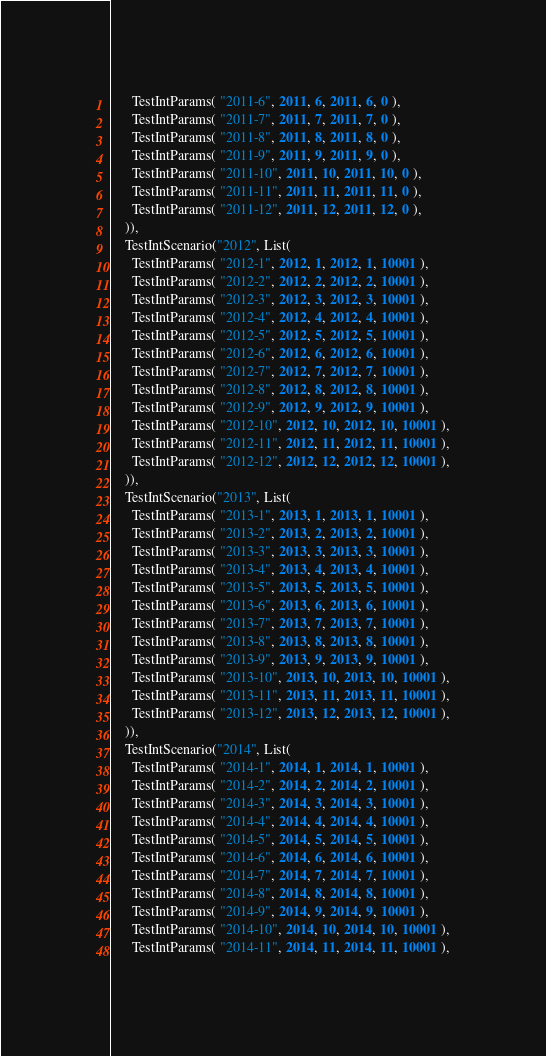Convert code to text. <code><loc_0><loc_0><loc_500><loc_500><_Scala_>      TestIntParams( "2011-6", 2011, 6, 2011, 6, 0 ),
      TestIntParams( "2011-7", 2011, 7, 2011, 7, 0 ),
      TestIntParams( "2011-8", 2011, 8, 2011, 8, 0 ),
      TestIntParams( "2011-9", 2011, 9, 2011, 9, 0 ),
      TestIntParams( "2011-10", 2011, 10, 2011, 10, 0 ),
      TestIntParams( "2011-11", 2011, 11, 2011, 11, 0 ),
      TestIntParams( "2011-12", 2011, 12, 2011, 12, 0 ),
    )),
    TestIntScenario("2012", List(
      TestIntParams( "2012-1", 2012, 1, 2012, 1, 10001 ),
      TestIntParams( "2012-2", 2012, 2, 2012, 2, 10001 ),
      TestIntParams( "2012-3", 2012, 3, 2012, 3, 10001 ),
      TestIntParams( "2012-4", 2012, 4, 2012, 4, 10001 ),
      TestIntParams( "2012-5", 2012, 5, 2012, 5, 10001 ),
      TestIntParams( "2012-6", 2012, 6, 2012, 6, 10001 ),
      TestIntParams( "2012-7", 2012, 7, 2012, 7, 10001 ),
      TestIntParams( "2012-8", 2012, 8, 2012, 8, 10001 ),
      TestIntParams( "2012-9", 2012, 9, 2012, 9, 10001 ),
      TestIntParams( "2012-10", 2012, 10, 2012, 10, 10001 ),
      TestIntParams( "2012-11", 2012, 11, 2012, 11, 10001 ),
      TestIntParams( "2012-12", 2012, 12, 2012, 12, 10001 ),
    )),
    TestIntScenario("2013", List(
      TestIntParams( "2013-1", 2013, 1, 2013, 1, 10001 ),
      TestIntParams( "2013-2", 2013, 2, 2013, 2, 10001 ),
      TestIntParams( "2013-3", 2013, 3, 2013, 3, 10001 ),
      TestIntParams( "2013-4", 2013, 4, 2013, 4, 10001 ),
      TestIntParams( "2013-5", 2013, 5, 2013, 5, 10001 ),
      TestIntParams( "2013-6", 2013, 6, 2013, 6, 10001 ),
      TestIntParams( "2013-7", 2013, 7, 2013, 7, 10001 ),
      TestIntParams( "2013-8", 2013, 8, 2013, 8, 10001 ),
      TestIntParams( "2013-9", 2013, 9, 2013, 9, 10001 ),
      TestIntParams( "2013-10", 2013, 10, 2013, 10, 10001 ),
      TestIntParams( "2013-11", 2013, 11, 2013, 11, 10001 ),
      TestIntParams( "2013-12", 2013, 12, 2013, 12, 10001 ),
    )),
    TestIntScenario("2014", List(
      TestIntParams( "2014-1", 2014, 1, 2014, 1, 10001 ),
      TestIntParams( "2014-2", 2014, 2, 2014, 2, 10001 ),
      TestIntParams( "2014-3", 2014, 3, 2014, 3, 10001 ),
      TestIntParams( "2014-4", 2014, 4, 2014, 4, 10001 ),
      TestIntParams( "2014-5", 2014, 5, 2014, 5, 10001 ),
      TestIntParams( "2014-6", 2014, 6, 2014, 6, 10001 ),
      TestIntParams( "2014-7", 2014, 7, 2014, 7, 10001 ),
      TestIntParams( "2014-8", 2014, 8, 2014, 8, 10001 ),
      TestIntParams( "2014-9", 2014, 9, 2014, 9, 10001 ),
      TestIntParams( "2014-10", 2014, 10, 2014, 10, 10001 ),
      TestIntParams( "2014-11", 2014, 11, 2014, 11, 10001 ),</code> 